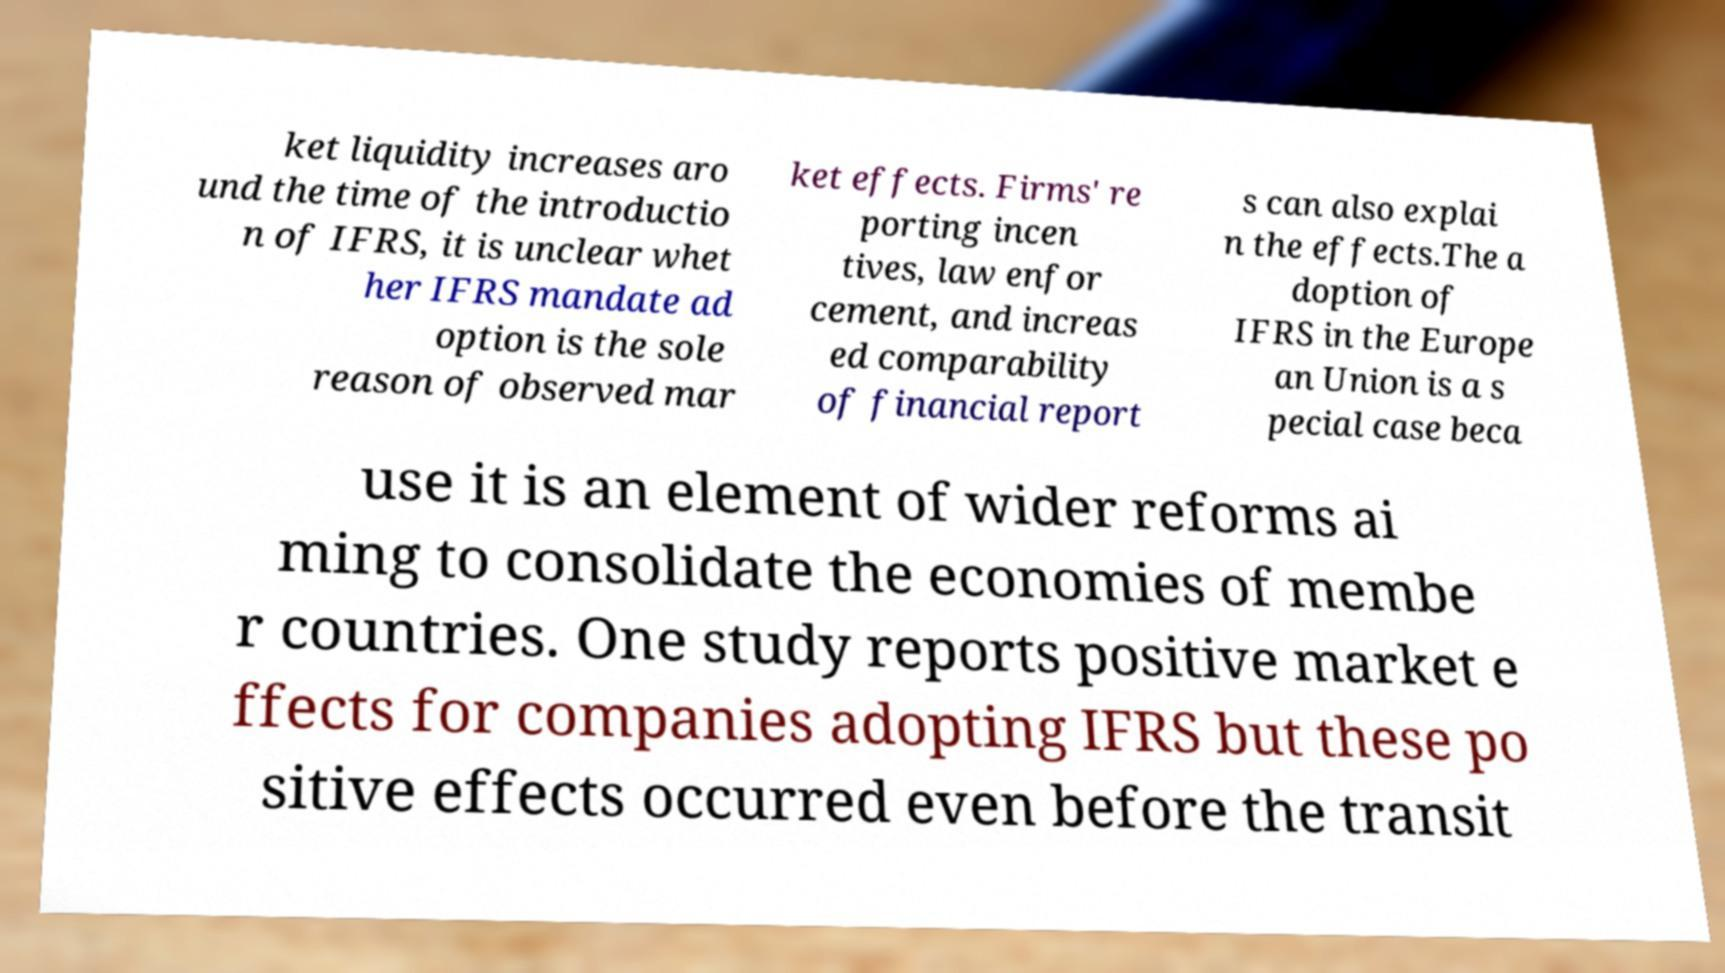I need the written content from this picture converted into text. Can you do that? ket liquidity increases aro und the time of the introductio n of IFRS, it is unclear whet her IFRS mandate ad option is the sole reason of observed mar ket effects. Firms' re porting incen tives, law enfor cement, and increas ed comparability of financial report s can also explai n the effects.The a doption of IFRS in the Europe an Union is a s pecial case beca use it is an element of wider reforms ai ming to consolidate the economies of membe r countries. One study reports positive market e ffects for companies adopting IFRS but these po sitive effects occurred even before the transit 